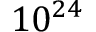<formula> <loc_0><loc_0><loc_500><loc_500>1 0 ^ { 2 4 }</formula> 